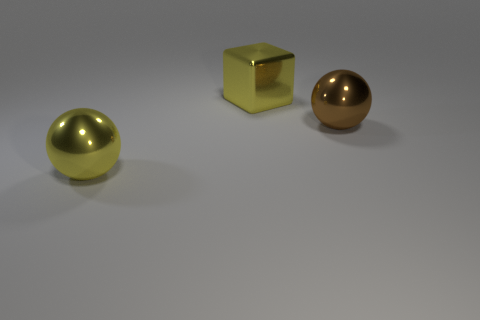Add 3 yellow objects. How many objects exist? 6 Subtract all balls. How many objects are left? 1 Subtract 0 green spheres. How many objects are left? 3 Subtract all tiny yellow matte cylinders. Subtract all big yellow cubes. How many objects are left? 2 Add 1 yellow cubes. How many yellow cubes are left? 2 Add 3 brown metallic spheres. How many brown metallic spheres exist? 4 